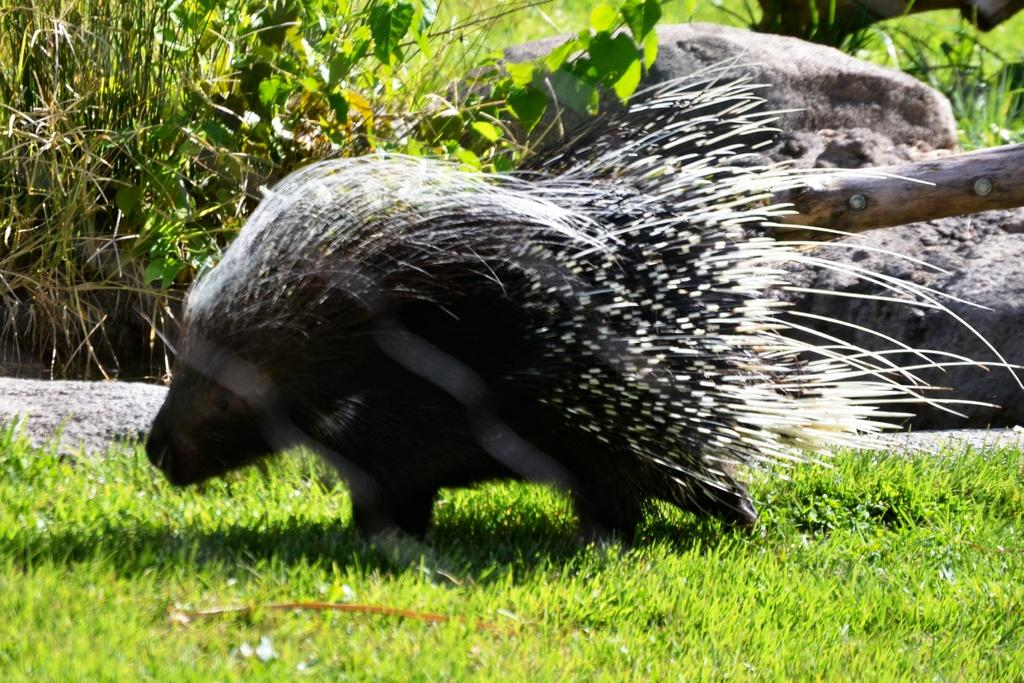What animal is in the picture? There is a porcupine in the picture. What type of terrain is visible in the picture? There is grass on the ground in the picture. What can be seen in the background of the picture? There are planets and a rock visible in the background of the picture. What type of hat is the porcupine wearing in the picture? There is no hat present in the picture; the porcupine is not wearing any clothing or accessories. 